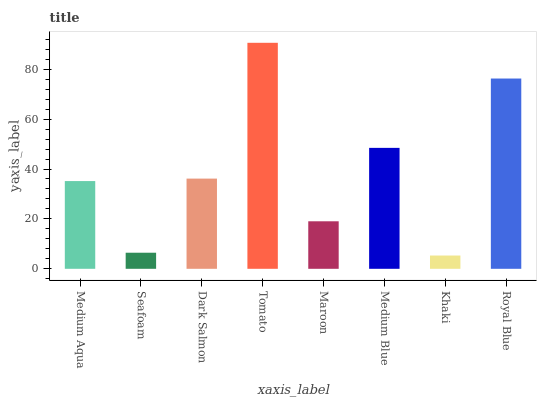Is Khaki the minimum?
Answer yes or no. Yes. Is Tomato the maximum?
Answer yes or no. Yes. Is Seafoam the minimum?
Answer yes or no. No. Is Seafoam the maximum?
Answer yes or no. No. Is Medium Aqua greater than Seafoam?
Answer yes or no. Yes. Is Seafoam less than Medium Aqua?
Answer yes or no. Yes. Is Seafoam greater than Medium Aqua?
Answer yes or no. No. Is Medium Aqua less than Seafoam?
Answer yes or no. No. Is Dark Salmon the high median?
Answer yes or no. Yes. Is Medium Aqua the low median?
Answer yes or no. Yes. Is Maroon the high median?
Answer yes or no. No. Is Seafoam the low median?
Answer yes or no. No. 